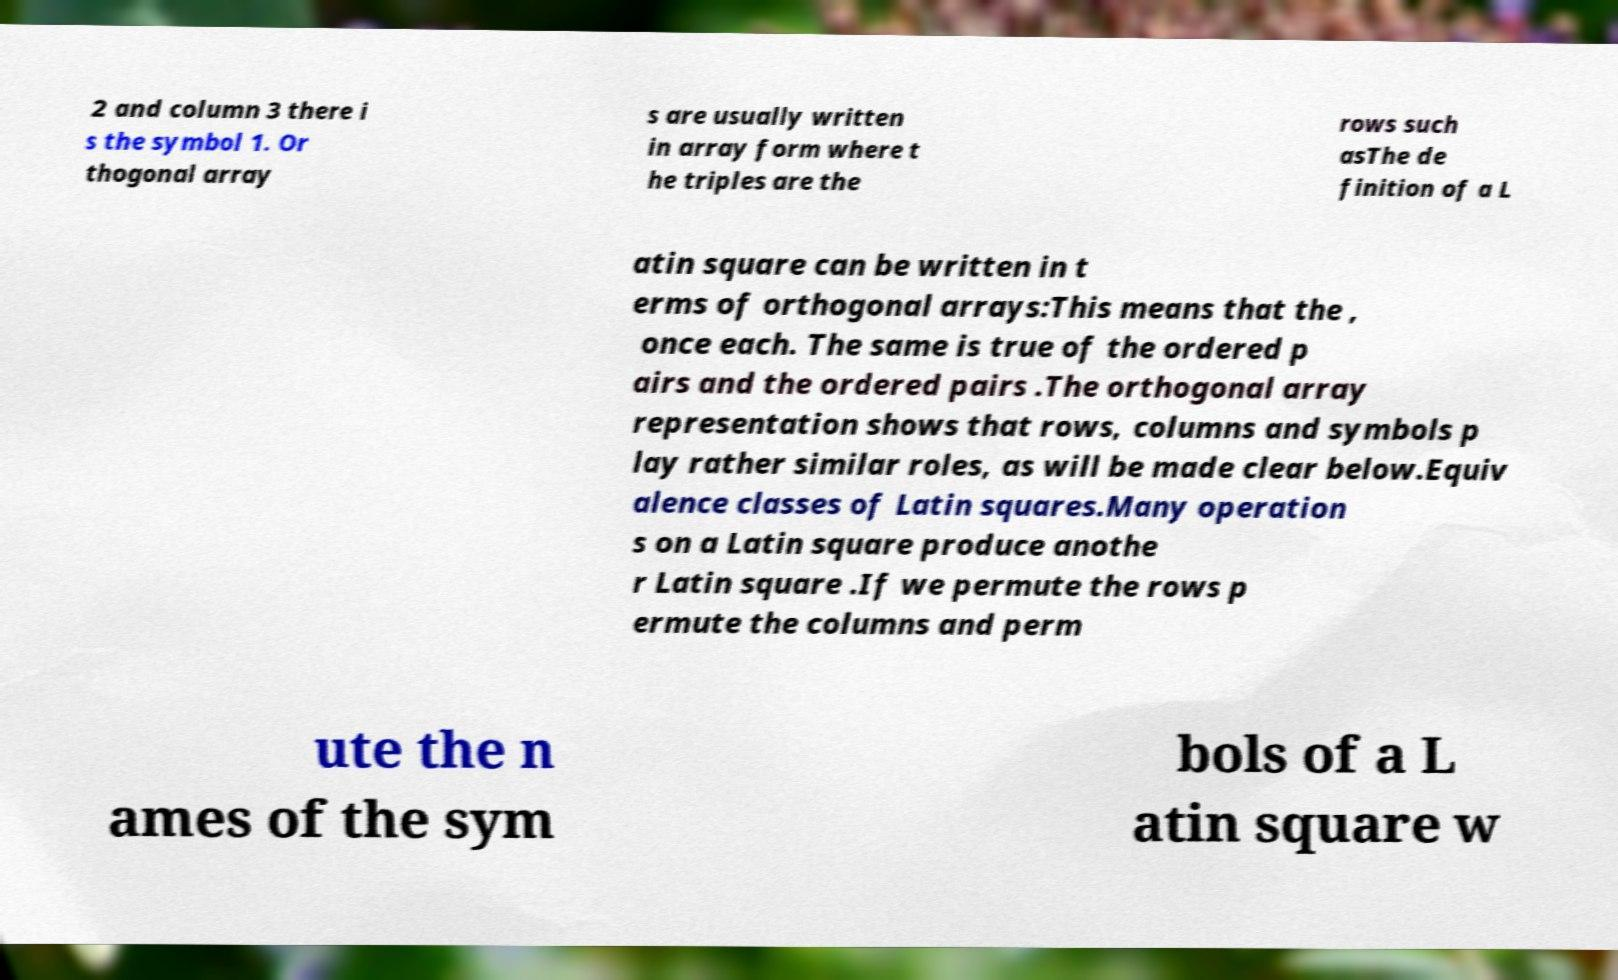For documentation purposes, I need the text within this image transcribed. Could you provide that? 2 and column 3 there i s the symbol 1. Or thogonal array s are usually written in array form where t he triples are the rows such asThe de finition of a L atin square can be written in t erms of orthogonal arrays:This means that the , once each. The same is true of the ordered p airs and the ordered pairs .The orthogonal array representation shows that rows, columns and symbols p lay rather similar roles, as will be made clear below.Equiv alence classes of Latin squares.Many operation s on a Latin square produce anothe r Latin square .If we permute the rows p ermute the columns and perm ute the n ames of the sym bols of a L atin square w 